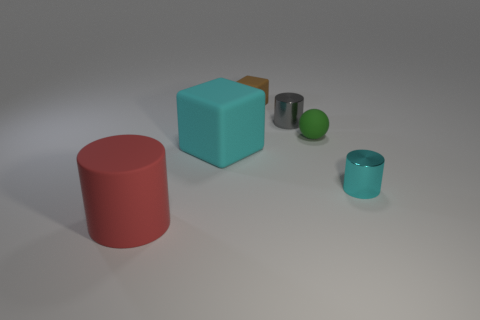Add 2 tiny gray things. How many objects exist? 8 Subtract all balls. How many objects are left? 5 Subtract 0 yellow blocks. How many objects are left? 6 Subtract all tiny cyan matte things. Subtract all gray objects. How many objects are left? 5 Add 6 green things. How many green things are left? 7 Add 5 tiny red metal things. How many tiny red metal things exist? 5 